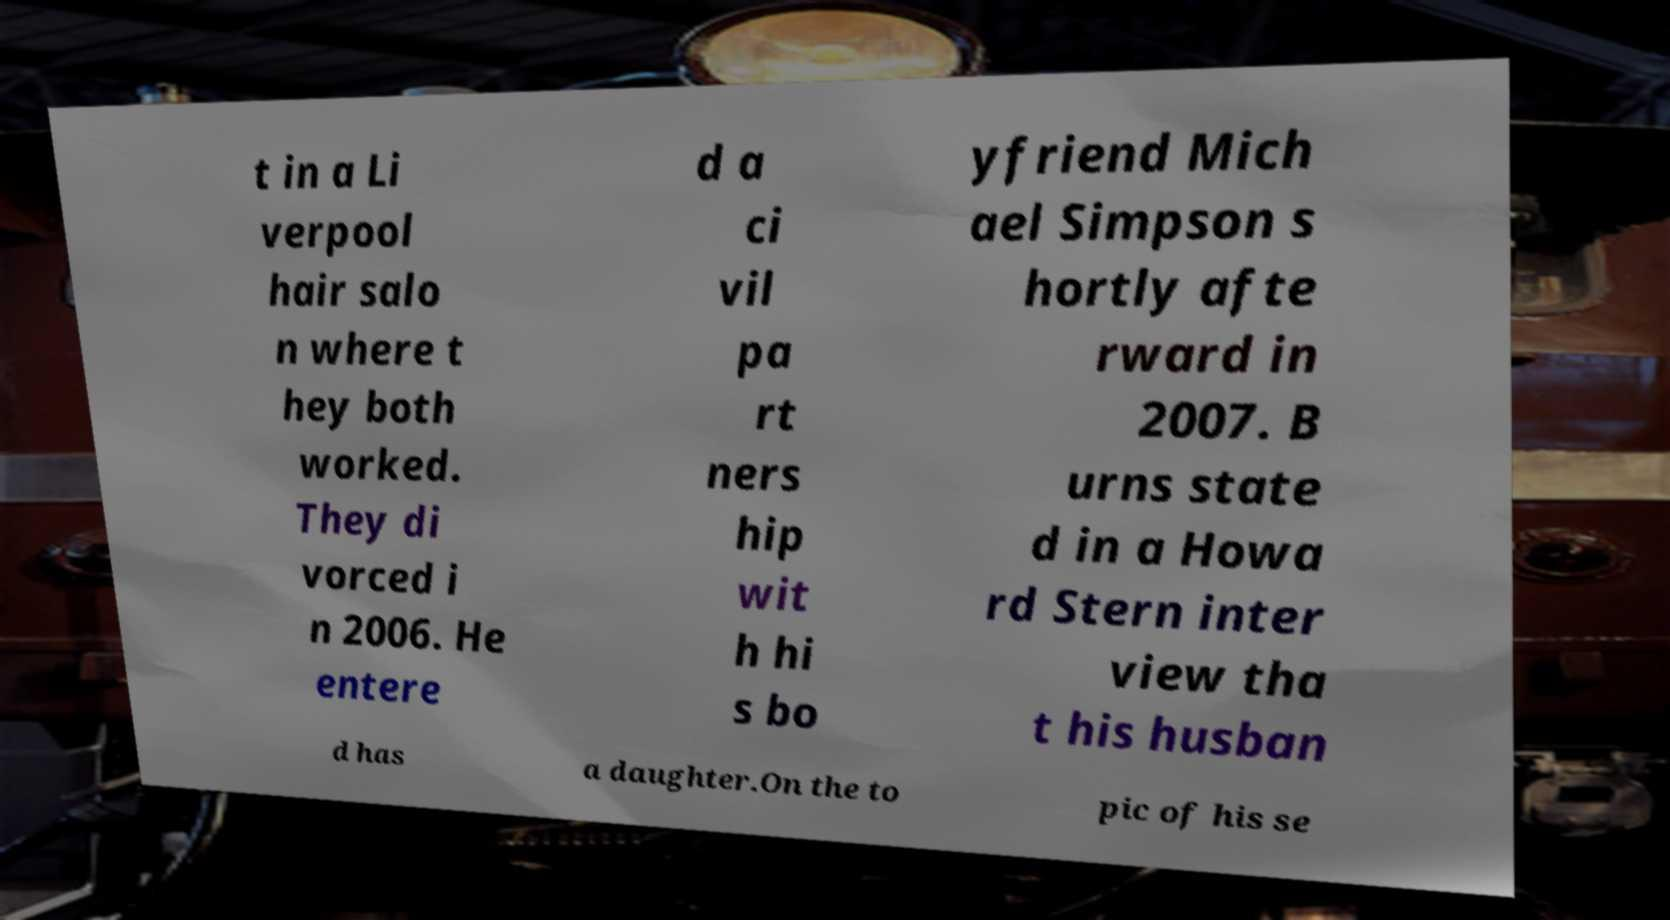What messages or text are displayed in this image? I need them in a readable, typed format. t in a Li verpool hair salo n where t hey both worked. They di vorced i n 2006. He entere d a ci vil pa rt ners hip wit h hi s bo yfriend Mich ael Simpson s hortly afte rward in 2007. B urns state d in a Howa rd Stern inter view tha t his husban d has a daughter.On the to pic of his se 